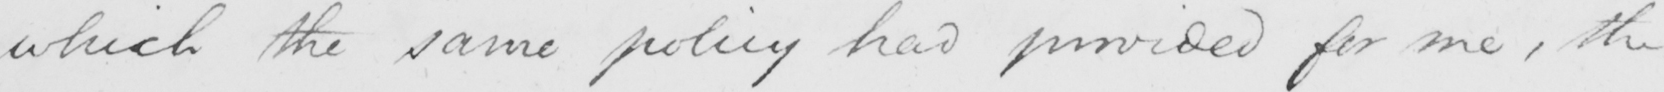Please provide the text content of this handwritten line. which the same policy had provided for me , the 